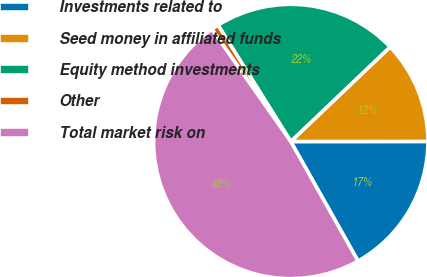<chart> <loc_0><loc_0><loc_500><loc_500><pie_chart><fcel>Investments related to<fcel>Seed money in affiliated funds<fcel>Equity method investments<fcel>Other<fcel>Total market risk on<nl><fcel>16.85%<fcel>12.1%<fcel>21.78%<fcel>0.86%<fcel>48.41%<nl></chart> 